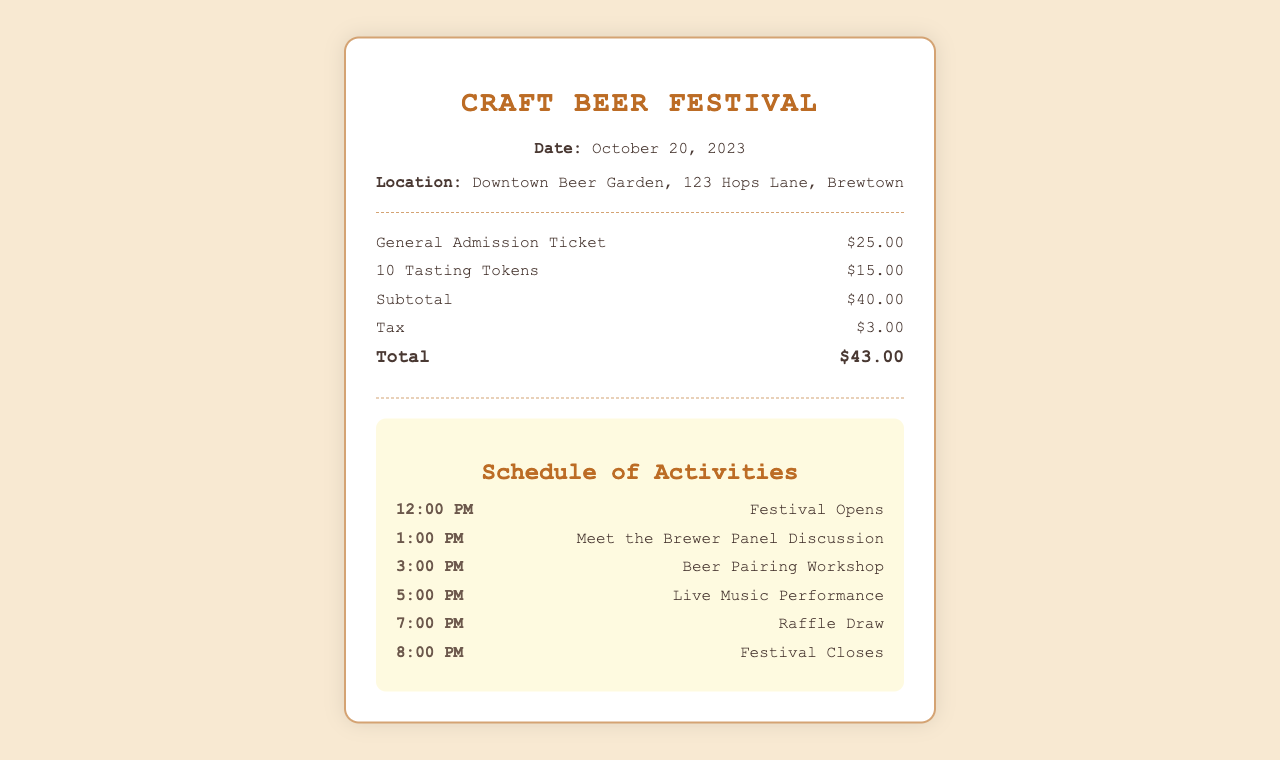What is the date of the festival? The date of the festival is mentioned in the event details section of the document.
Answer: October 20, 2023 What is the location of the festival? The location is stated in the event details section.
Answer: Downtown Beer Garden, 123 Hops Lane, Brewtown How much is the general admission ticket? This information is found in the cost breakdown section.
Answer: $25.00 How many tasting tokens are included? The number of tasting tokens is listed in the cost breakdown.
Answer: 10 Tasting Tokens What is the total amount after tax? The total amount is the sum of the subtotal and tax, which can be found in the cost breakdown.
Answer: $43.00 What time does the festival open? The opening time is provided in the schedule of activities.
Answer: 12:00 PM What activity starts at 5:00 PM? This information can be found in the schedule of activities section.
Answer: Live Music Performance What is the last activity before the festival closes? The last activity is listed in the schedule, just before the festival closes.
Answer: Raffle Draw 